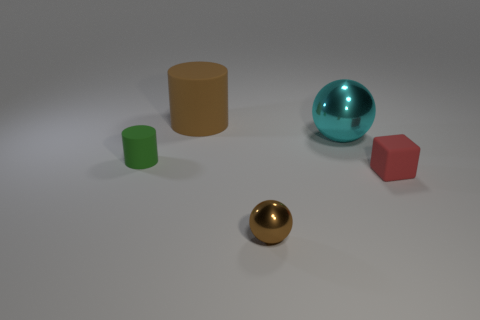Subtract all brown balls. How many balls are left? 1 Add 2 big gray cylinders. How many objects exist? 7 Subtract 1 balls. How many balls are left? 1 Subtract all green cylinders. Subtract all yellow balls. How many cylinders are left? 1 Subtract all small shiny objects. Subtract all green rubber cylinders. How many objects are left? 3 Add 2 tiny objects. How many tiny objects are left? 5 Add 2 big cyan metal balls. How many big cyan metal balls exist? 3 Subtract 0 gray cylinders. How many objects are left? 5 Subtract all cylinders. How many objects are left? 3 